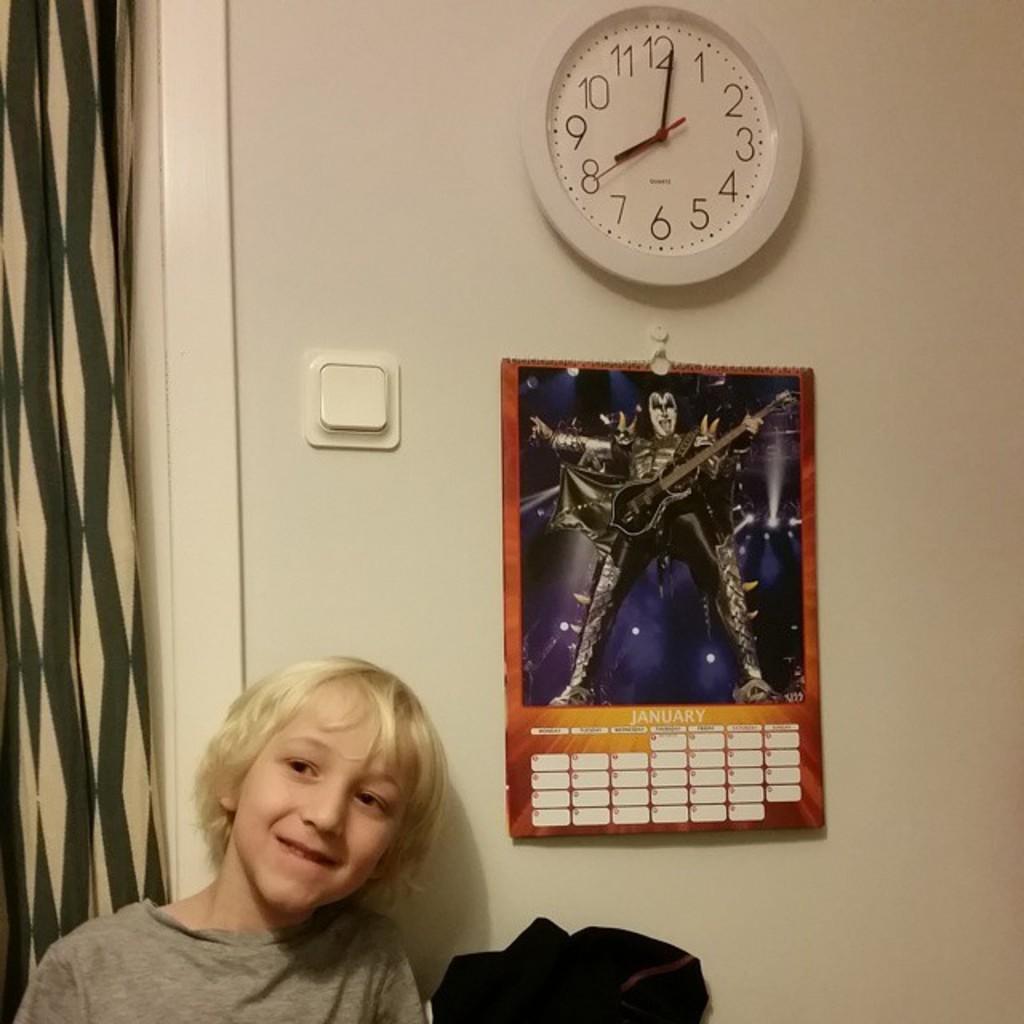What month is the calendar?
Your answer should be very brief. January. What time does the clock say?
Your answer should be compact. 8:01. 